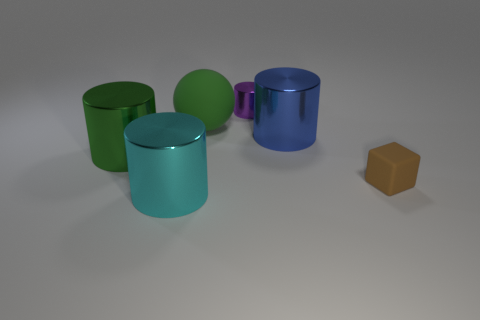There is a thing that is on the left side of the blue metallic object and in front of the green shiny cylinder; what size is it?
Your answer should be very brief. Large. What is the shape of the metallic thing that is in front of the big green object that is to the left of the big cyan metallic object?
Ensure brevity in your answer.  Cylinder. Is there any other thing that is the same color as the cube?
Give a very brief answer. No. There is a green thing that is left of the cyan object; what shape is it?
Provide a succinct answer. Cylinder. What shape is the thing that is both behind the small brown block and left of the green sphere?
Offer a very short reply. Cylinder. How many green objects are large metal cylinders or small cylinders?
Provide a short and direct response. 1. There is a shiny cylinder left of the cyan thing; is its color the same as the ball?
Offer a terse response. Yes. What size is the matte thing that is to the right of the tiny thing behind the tiny rubber cube?
Ensure brevity in your answer.  Small. What is the material of the green thing that is the same size as the green sphere?
Keep it short and to the point. Metal. What number of other things are there of the same size as the brown thing?
Provide a succinct answer. 1. 